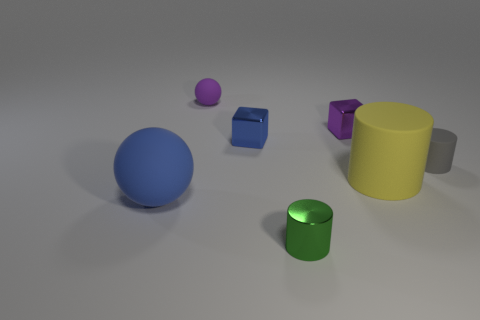Add 1 brown rubber blocks. How many objects exist? 8 Subtract all yellow cylinders. How many cylinders are left? 2 Subtract all rubber cylinders. How many cylinders are left? 1 Subtract 1 cubes. How many cubes are left? 1 Add 6 small green shiny cylinders. How many small green shiny cylinders are left? 7 Add 4 rubber things. How many rubber things exist? 8 Subtract 1 yellow cylinders. How many objects are left? 6 Subtract all spheres. How many objects are left? 5 Subtract all brown cylinders. Subtract all cyan blocks. How many cylinders are left? 3 Subtract all brown cubes. How many gray balls are left? 0 